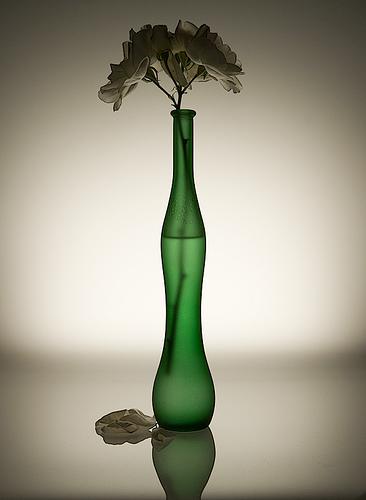Are these vessels transparent?
Write a very short answer. Yes. How many flowers are in the vase?
Quick response, please. 3. What fruit is the drink in the glass made out of?
Keep it brief. Lemon. Which direction is the light coming from?
Concise answer only. Behind. Are the flowers white?
Short answer required. Yes. At these vases handmade?
Concise answer only. No. Where are the plants?
Write a very short answer. Vase. What color is the vase?
Write a very short answer. Green. Is this a mirror?
Give a very brief answer. No. Do the flowers look fresh?
Short answer required. No. Whose face is that?
Be succinct. No face. 